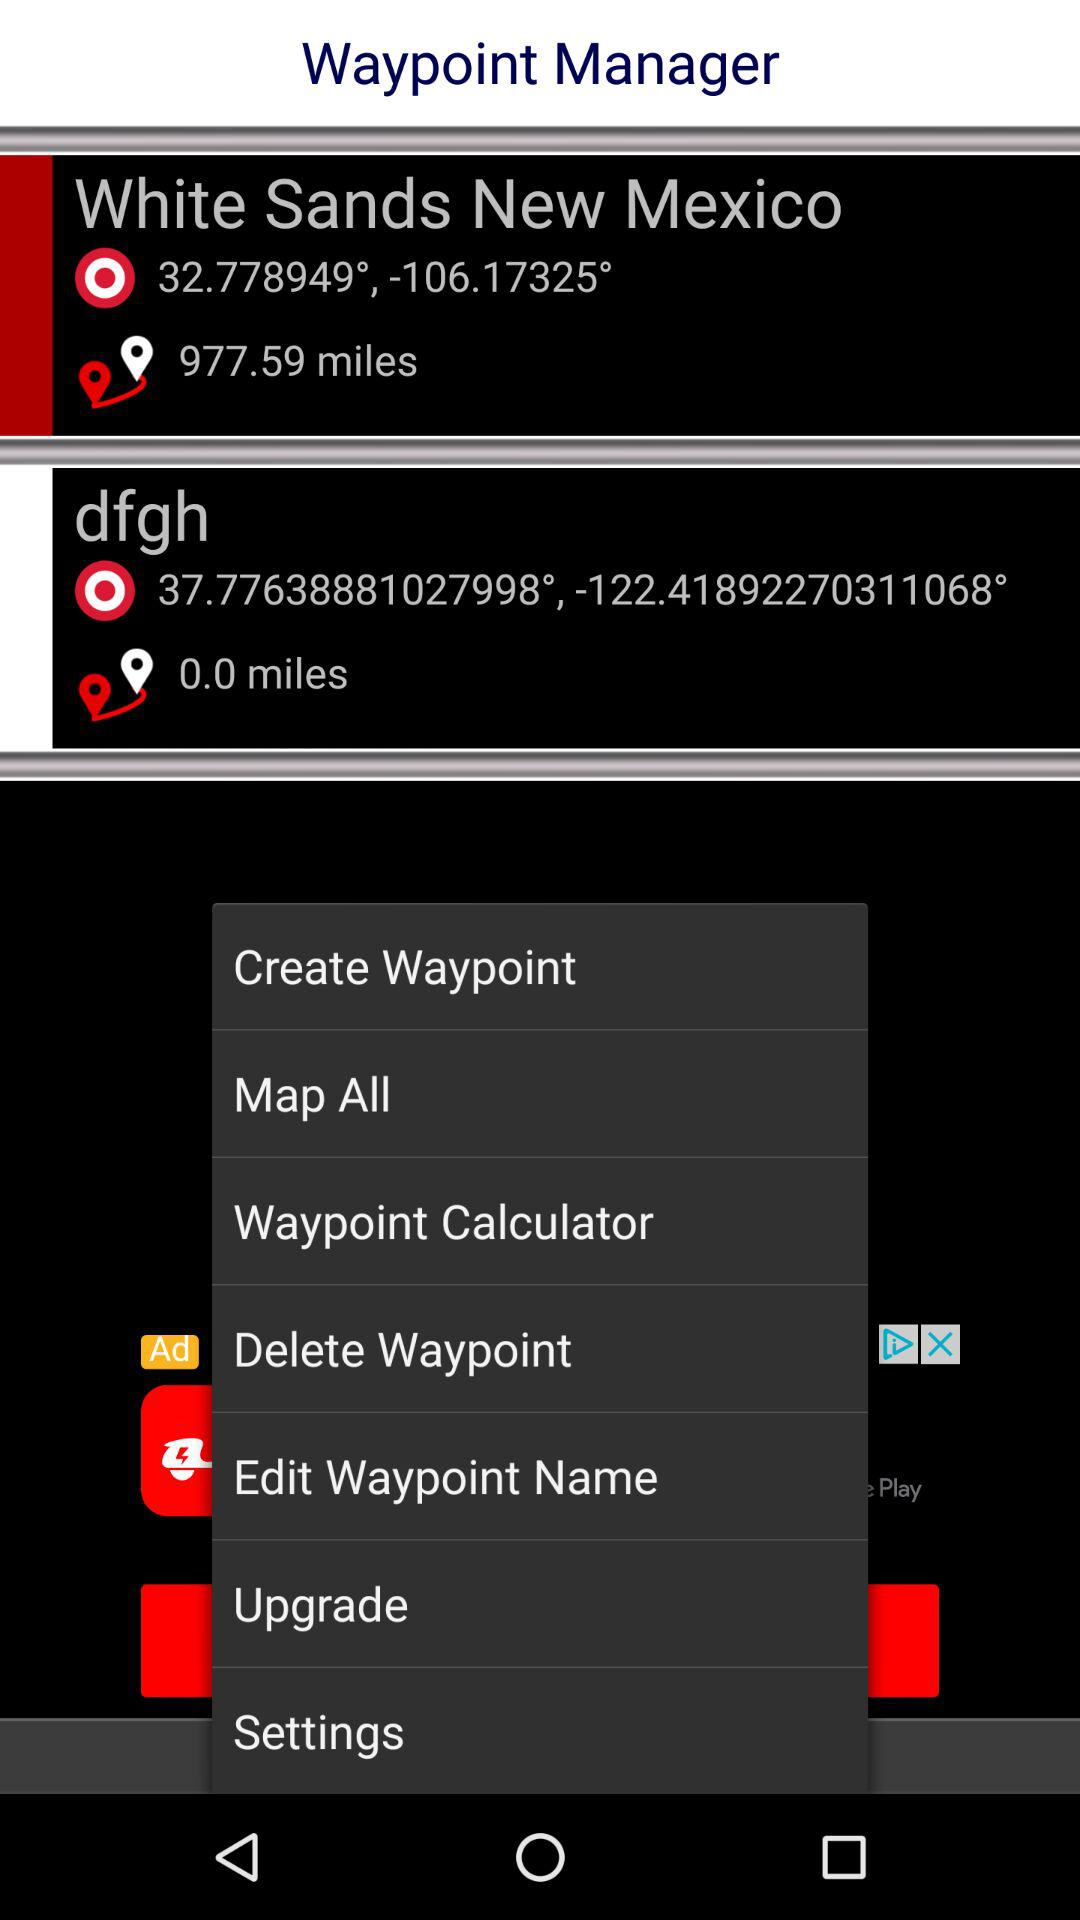What is the latitude and longitude of "White Sands New Mexico"? The latitude and longitude are 32.778949° and -106.17325°. 